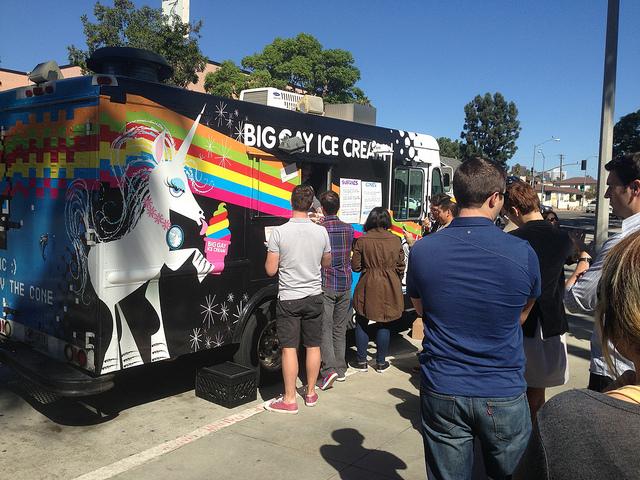Is the ice cream gay?
Keep it brief. Yes. Is that my little pony?
Quick response, please. No. What sexuality is represented by the truck company?
Concise answer only. Gay. 